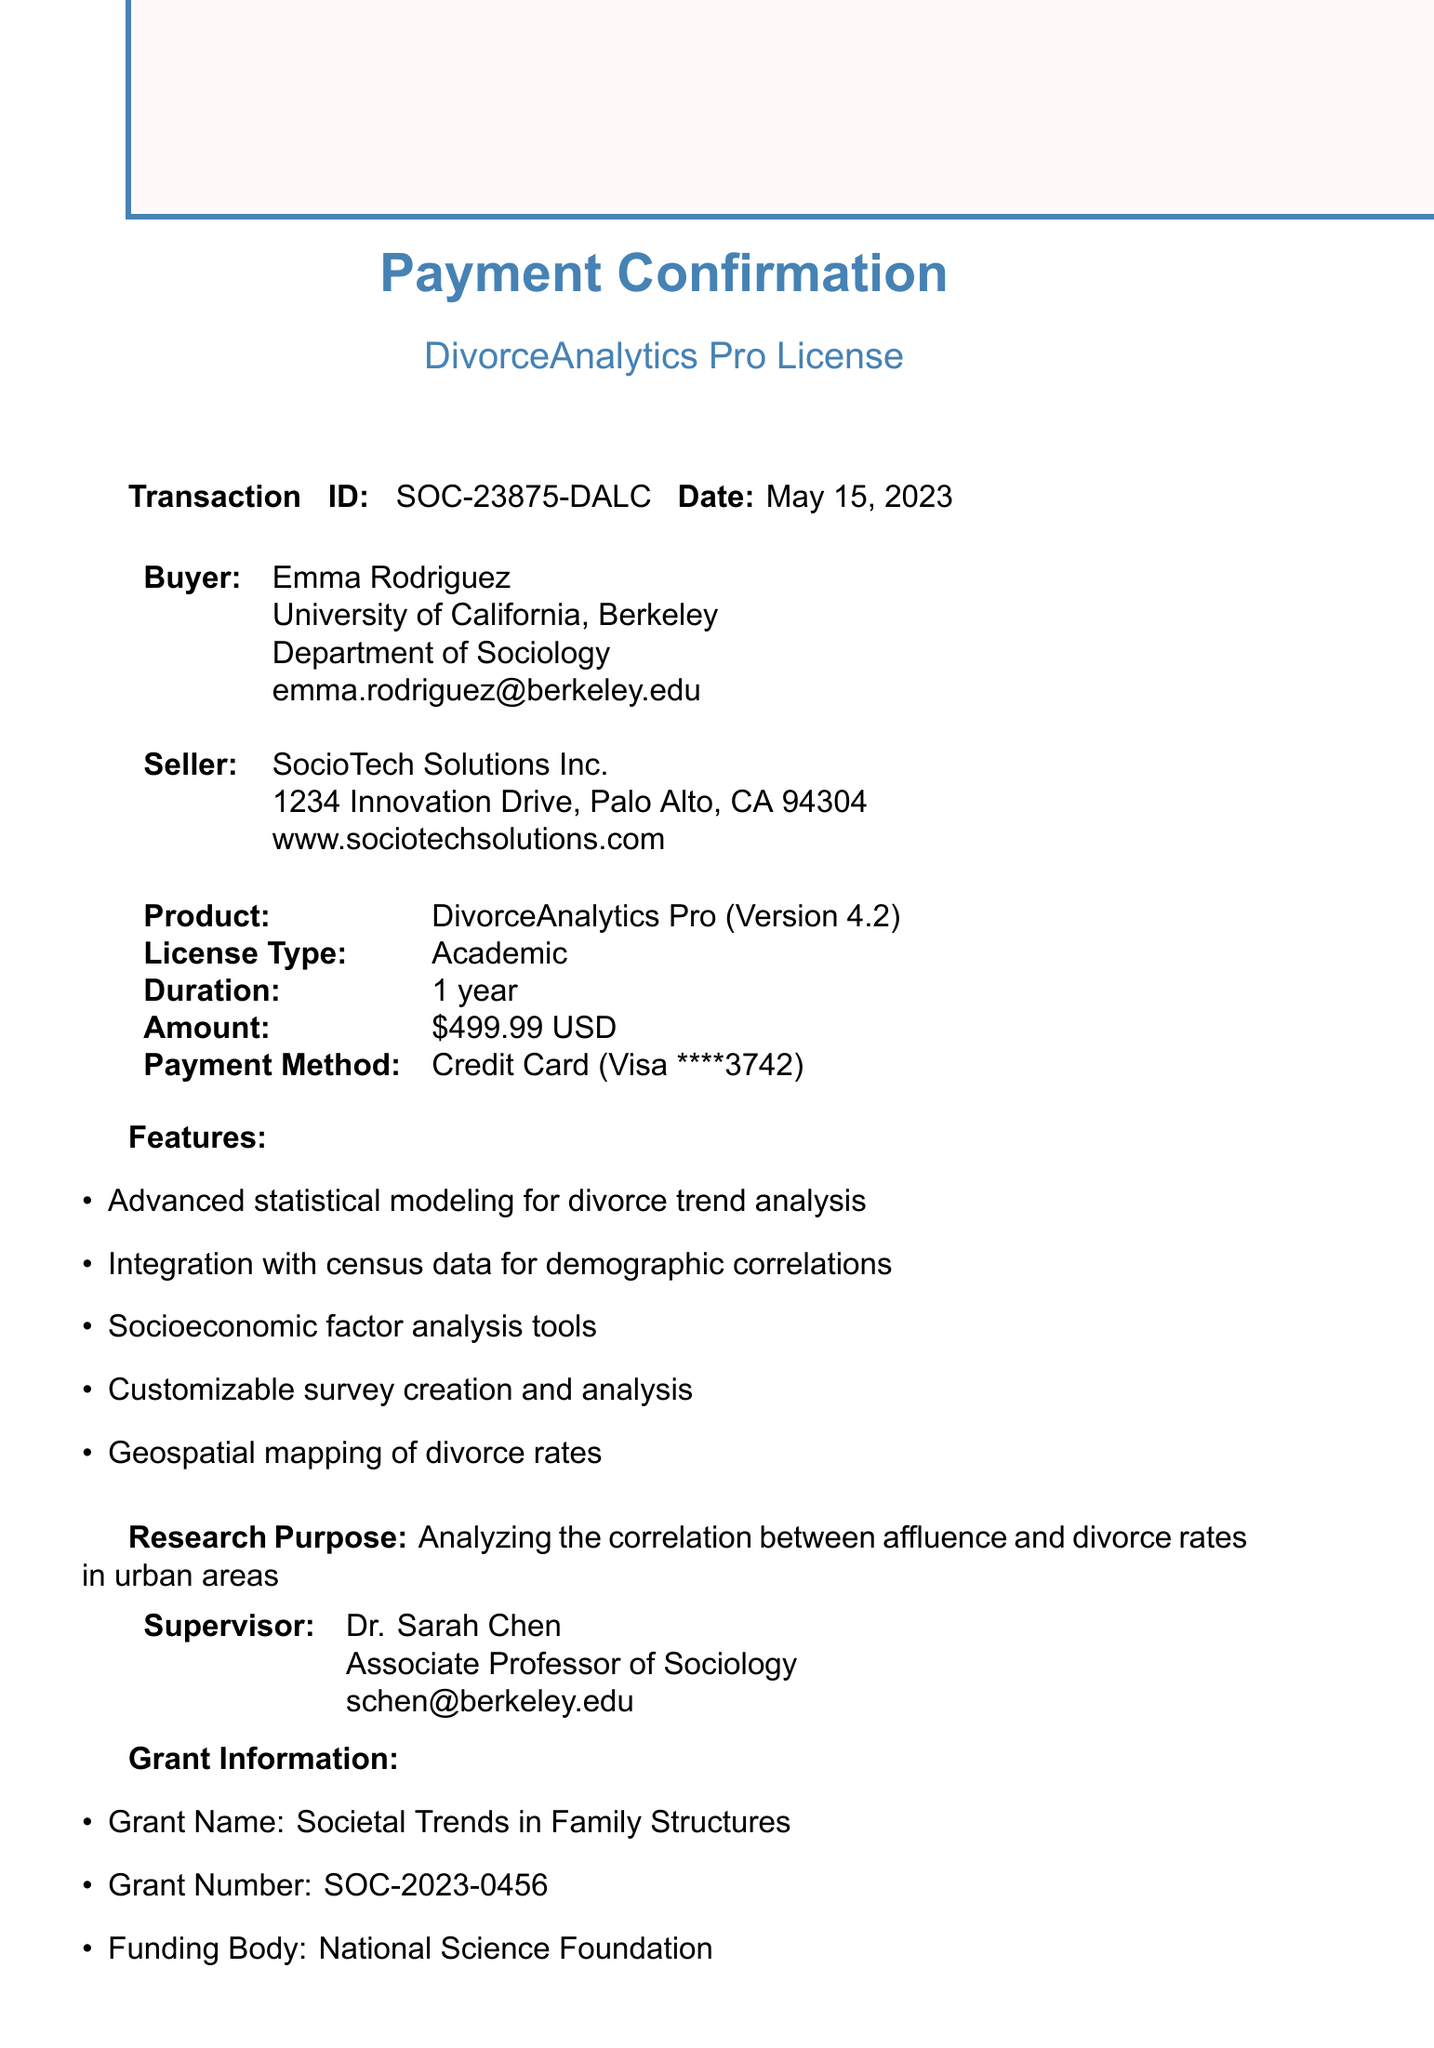What is the transaction ID? The transaction ID is explicitly stated in the document and is SOC-23875-DALC.
Answer: SOC-23875-DALC Who is the buyer? The buyer's name is provided in the document, which is Emma Rodriguez.
Answer: Emma Rodriguez What is the amount paid? The amount paid is listed in the payment details section, which is $499.99.
Answer: $499.99 What is the duration of the software license? The duration of the license is mentioned in the product details, which is 1 year.
Answer: 1 year What is the research purpose? The research purpose is explicitly outlined in the document as analyzing the correlation between affluence and divorce rates in urban areas.
Answer: Analyzing the correlation between affluence and divorce rates in urban areas Who is the funding body? The funding body is listed in the grant information section and is the National Science Foundation.
Answer: National Science Foundation What features does the software license include? The features are listed in the document, including advanced statistical modeling, integration with census data, and more.
Answer: Advanced statistical modeling for divorce trend analysis, Integration with census data for demographic correlations, Socioeconomic factor analysis tools, Customizable survey creation and analysis, Geospatial mapping of divorce rates What is the technical support email? The email for technical support is provided in the document, which is support@sociotechsolutions.com.
Answer: support@sociotechsolutions.com What is the supervisor’s name? The supervisor's name is detailed in the document and is Dr. Sarah Chen.
Answer: Dr. Sarah Chen 